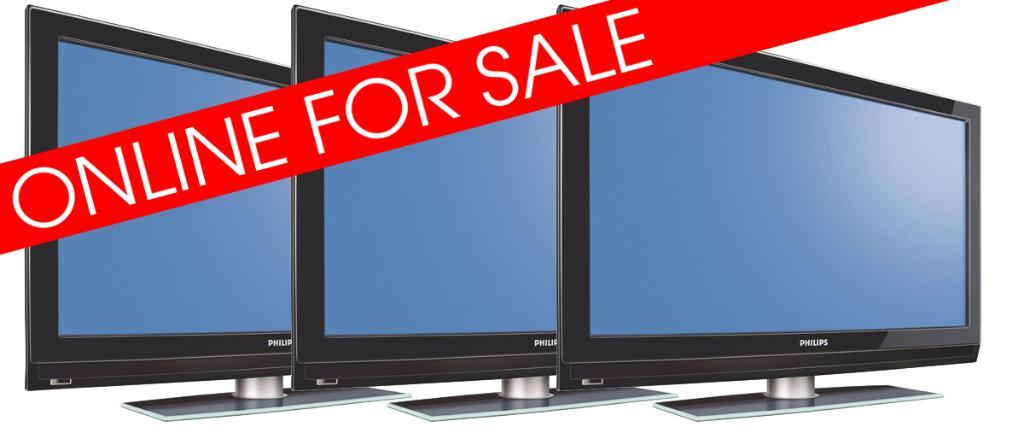<image>
Summarize the visual content of the image. Some TV screens with For Sale in a red banner over them. 